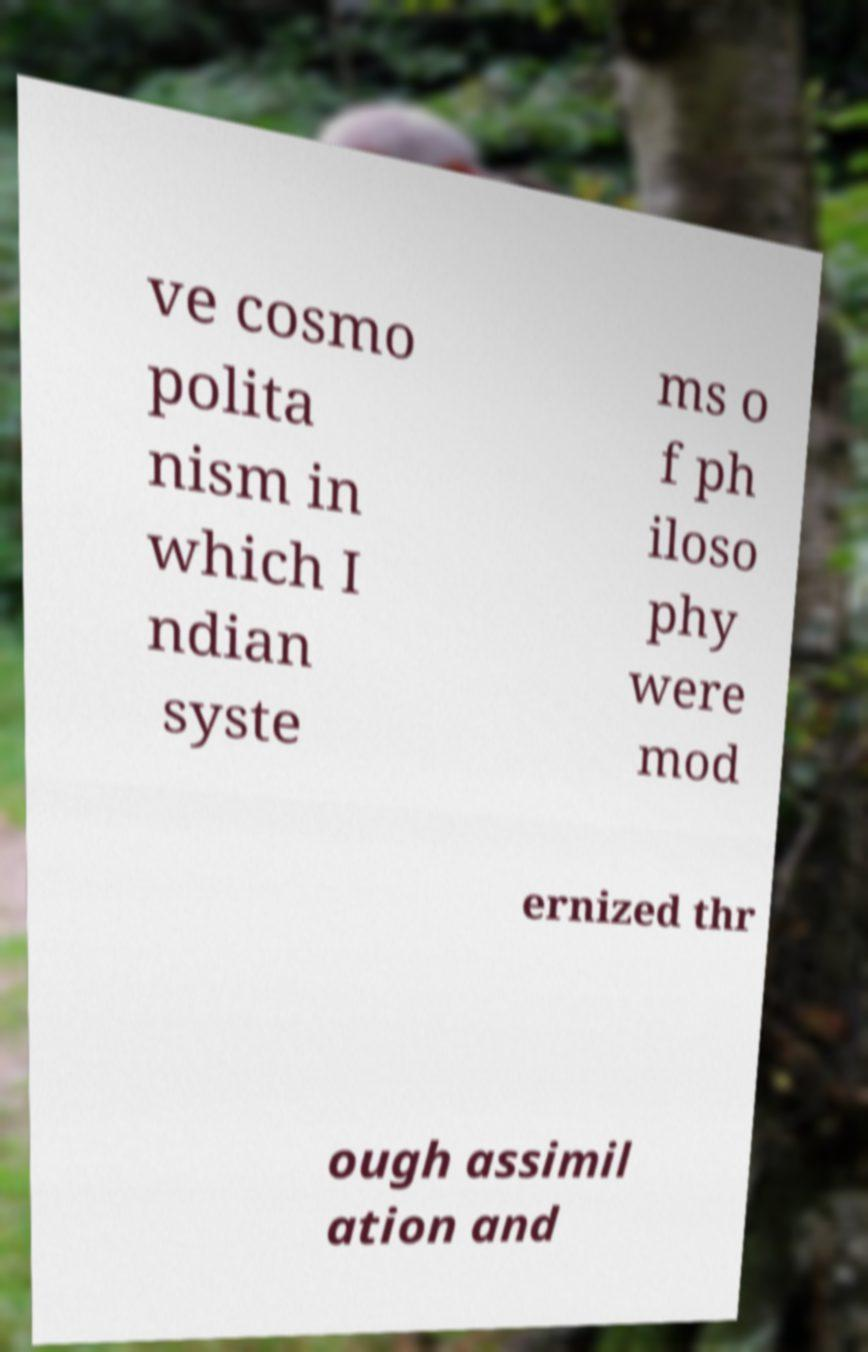I need the written content from this picture converted into text. Can you do that? ve cosmo polita nism in which I ndian syste ms o f ph iloso phy were mod ernized thr ough assimil ation and 